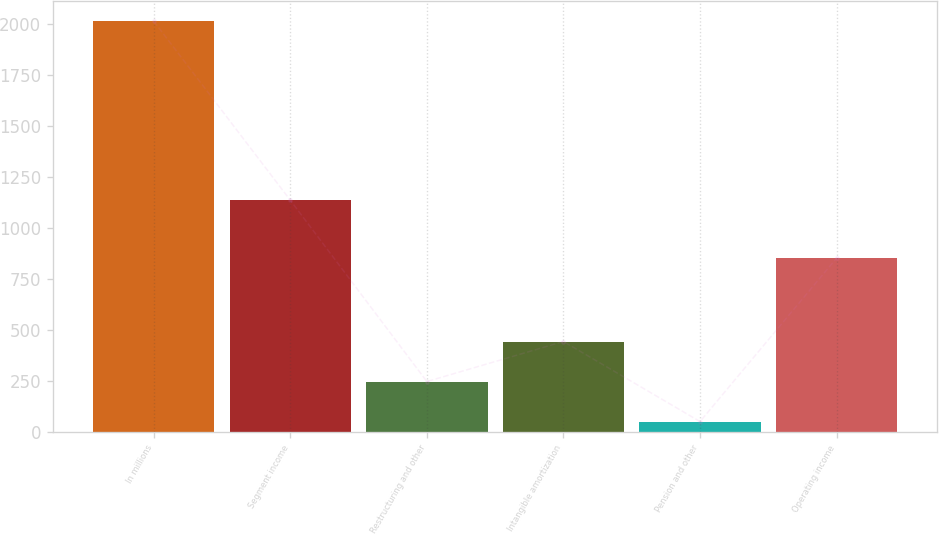<chart> <loc_0><loc_0><loc_500><loc_500><bar_chart><fcel>In millions<fcel>Segment income<fcel>Restructuring and other<fcel>Intangible amortization<fcel>Pension and other<fcel>Operating income<nl><fcel>2014<fcel>1135.7<fcel>246.31<fcel>442.72<fcel>49.9<fcel>851.9<nl></chart> 